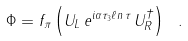Convert formula to latex. <formula><loc_0><loc_0><loc_500><loc_500>\Phi = f _ { \pi } \left ( U _ { L } \, e ^ { i \alpha \tau _ { 3 } \ell n \, \tau } \, U ^ { \dagger } _ { R } \right ) \ .</formula> 